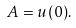Convert formula to latex. <formula><loc_0><loc_0><loc_500><loc_500>A = u ( 0 ) .</formula> 